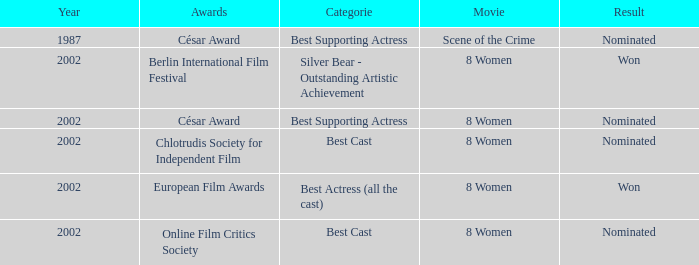In what year was the movie 8 women up for a César Award? 2002.0. 